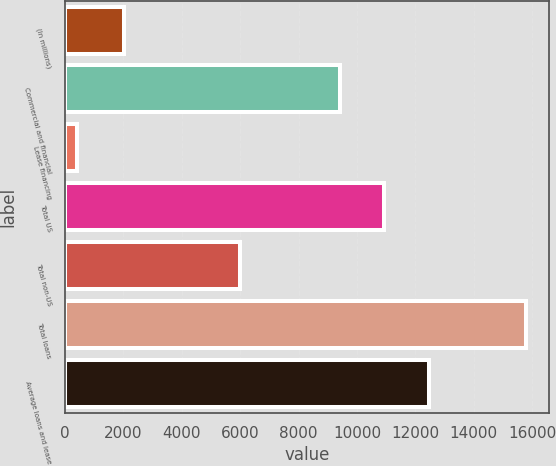<chart> <loc_0><loc_0><loc_500><loc_500><bar_chart><fcel>(In millions)<fcel>Commercial and financial<fcel>Lease financing<fcel>Total US<fcel>Total non-US<fcel>Total loans<fcel>Average loans and lease<nl><fcel>2007<fcel>9402<fcel>396<fcel>10942.6<fcel>6004<fcel>15802<fcel>12483.2<nl></chart> 